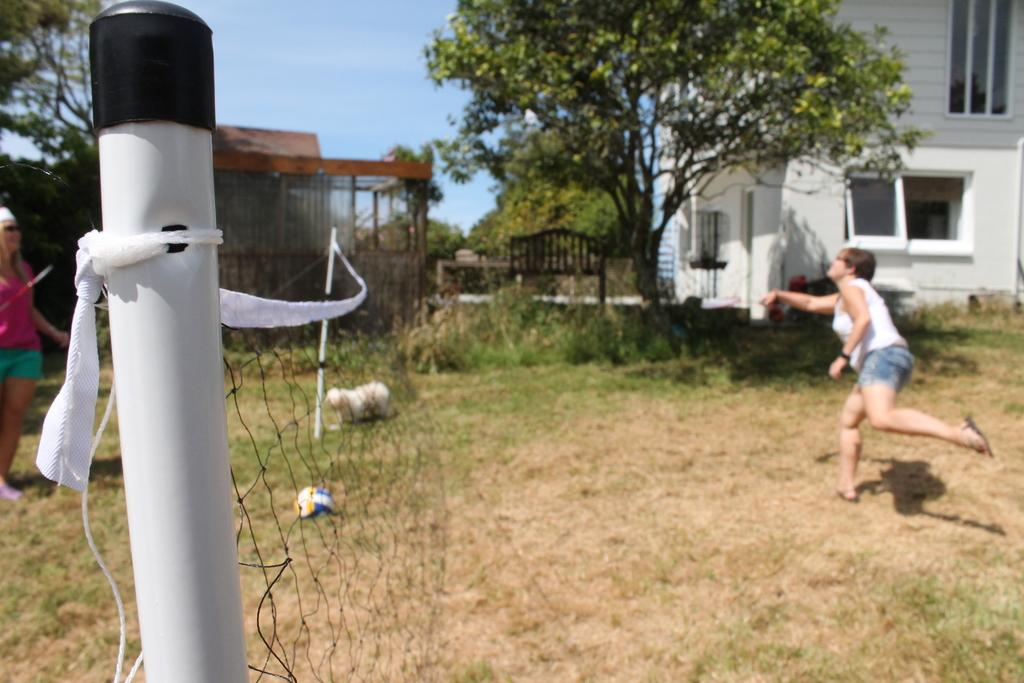What are the people in the image doing? The people in the image are on the ground, and there is a net visible between them, suggesting they might be playing a game or sport. What objects can be seen in the image? There are objects present in the image, but their specific nature is not mentioned in the facts. What can be seen in the background of the image? In the background of the image, there is a bench, buildings, trees, and the sky. How many zippers are visible on the people's clothing in the image? There is no mention of zippers on the people's clothing in the image, so it is impossible to determine their number. Is there a fight happening between the people in the image? There is no indication of a fight in the image; the people are engaged in an activity involving a net, which suggests a game or sport. 